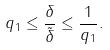<formula> <loc_0><loc_0><loc_500><loc_500>q _ { 1 } \leq \frac { \delta } { \tilde { \delta } } \leq \frac { 1 } { q _ { 1 } } .</formula> 